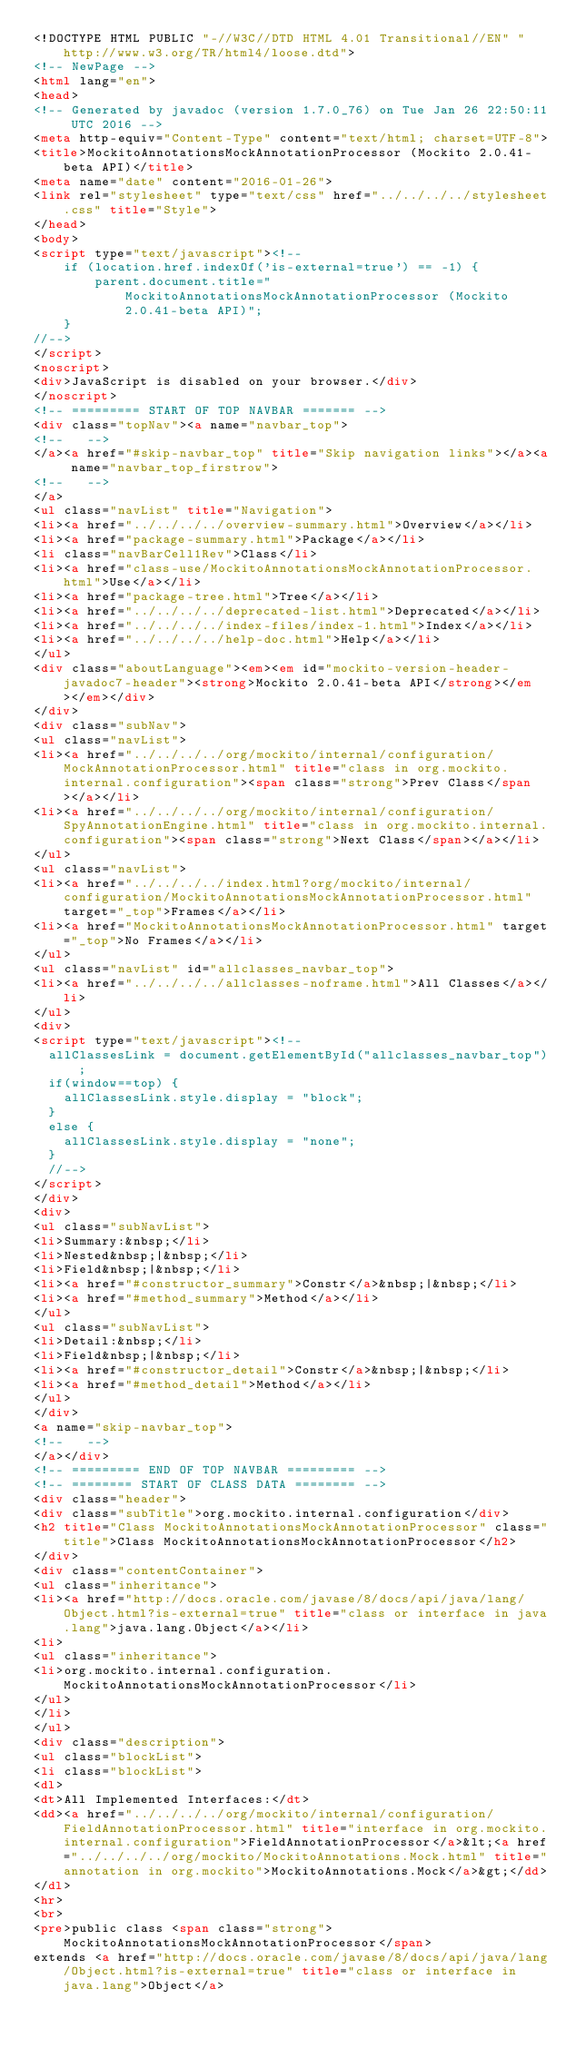<code> <loc_0><loc_0><loc_500><loc_500><_HTML_><!DOCTYPE HTML PUBLIC "-//W3C//DTD HTML 4.01 Transitional//EN" "http://www.w3.org/TR/html4/loose.dtd">
<!-- NewPage -->
<html lang="en">
<head>
<!-- Generated by javadoc (version 1.7.0_76) on Tue Jan 26 22:50:11 UTC 2016 -->
<meta http-equiv="Content-Type" content="text/html; charset=UTF-8">
<title>MockitoAnnotationsMockAnnotationProcessor (Mockito 2.0.41-beta API)</title>
<meta name="date" content="2016-01-26">
<link rel="stylesheet" type="text/css" href="../../../../stylesheet.css" title="Style">
</head>
<body>
<script type="text/javascript"><!--
    if (location.href.indexOf('is-external=true') == -1) {
        parent.document.title="MockitoAnnotationsMockAnnotationProcessor (Mockito 2.0.41-beta API)";
    }
//-->
</script>
<noscript>
<div>JavaScript is disabled on your browser.</div>
</noscript>
<!-- ========= START OF TOP NAVBAR ======= -->
<div class="topNav"><a name="navbar_top">
<!--   -->
</a><a href="#skip-navbar_top" title="Skip navigation links"></a><a name="navbar_top_firstrow">
<!--   -->
</a>
<ul class="navList" title="Navigation">
<li><a href="../../../../overview-summary.html">Overview</a></li>
<li><a href="package-summary.html">Package</a></li>
<li class="navBarCell1Rev">Class</li>
<li><a href="class-use/MockitoAnnotationsMockAnnotationProcessor.html">Use</a></li>
<li><a href="package-tree.html">Tree</a></li>
<li><a href="../../../../deprecated-list.html">Deprecated</a></li>
<li><a href="../../../../index-files/index-1.html">Index</a></li>
<li><a href="../../../../help-doc.html">Help</a></li>
</ul>
<div class="aboutLanguage"><em><em id="mockito-version-header-javadoc7-header"><strong>Mockito 2.0.41-beta API</strong></em></em></div>
</div>
<div class="subNav">
<ul class="navList">
<li><a href="../../../../org/mockito/internal/configuration/MockAnnotationProcessor.html" title="class in org.mockito.internal.configuration"><span class="strong">Prev Class</span></a></li>
<li><a href="../../../../org/mockito/internal/configuration/SpyAnnotationEngine.html" title="class in org.mockito.internal.configuration"><span class="strong">Next Class</span></a></li>
</ul>
<ul class="navList">
<li><a href="../../../../index.html?org/mockito/internal/configuration/MockitoAnnotationsMockAnnotationProcessor.html" target="_top">Frames</a></li>
<li><a href="MockitoAnnotationsMockAnnotationProcessor.html" target="_top">No Frames</a></li>
</ul>
<ul class="navList" id="allclasses_navbar_top">
<li><a href="../../../../allclasses-noframe.html">All Classes</a></li>
</ul>
<div>
<script type="text/javascript"><!--
  allClassesLink = document.getElementById("allclasses_navbar_top");
  if(window==top) {
    allClassesLink.style.display = "block";
  }
  else {
    allClassesLink.style.display = "none";
  }
  //-->
</script>
</div>
<div>
<ul class="subNavList">
<li>Summary:&nbsp;</li>
<li>Nested&nbsp;|&nbsp;</li>
<li>Field&nbsp;|&nbsp;</li>
<li><a href="#constructor_summary">Constr</a>&nbsp;|&nbsp;</li>
<li><a href="#method_summary">Method</a></li>
</ul>
<ul class="subNavList">
<li>Detail:&nbsp;</li>
<li>Field&nbsp;|&nbsp;</li>
<li><a href="#constructor_detail">Constr</a>&nbsp;|&nbsp;</li>
<li><a href="#method_detail">Method</a></li>
</ul>
</div>
<a name="skip-navbar_top">
<!--   -->
</a></div>
<!-- ========= END OF TOP NAVBAR ========= -->
<!-- ======== START OF CLASS DATA ======== -->
<div class="header">
<div class="subTitle">org.mockito.internal.configuration</div>
<h2 title="Class MockitoAnnotationsMockAnnotationProcessor" class="title">Class MockitoAnnotationsMockAnnotationProcessor</h2>
</div>
<div class="contentContainer">
<ul class="inheritance">
<li><a href="http://docs.oracle.com/javase/8/docs/api/java/lang/Object.html?is-external=true" title="class or interface in java.lang">java.lang.Object</a></li>
<li>
<ul class="inheritance">
<li>org.mockito.internal.configuration.MockitoAnnotationsMockAnnotationProcessor</li>
</ul>
</li>
</ul>
<div class="description">
<ul class="blockList">
<li class="blockList">
<dl>
<dt>All Implemented Interfaces:</dt>
<dd><a href="../../../../org/mockito/internal/configuration/FieldAnnotationProcessor.html" title="interface in org.mockito.internal.configuration">FieldAnnotationProcessor</a>&lt;<a href="../../../../org/mockito/MockitoAnnotations.Mock.html" title="annotation in org.mockito">MockitoAnnotations.Mock</a>&gt;</dd>
</dl>
<hr>
<br>
<pre>public class <span class="strong">MockitoAnnotationsMockAnnotationProcessor</span>
extends <a href="http://docs.oracle.com/javase/8/docs/api/java/lang/Object.html?is-external=true" title="class or interface in java.lang">Object</a></code> 